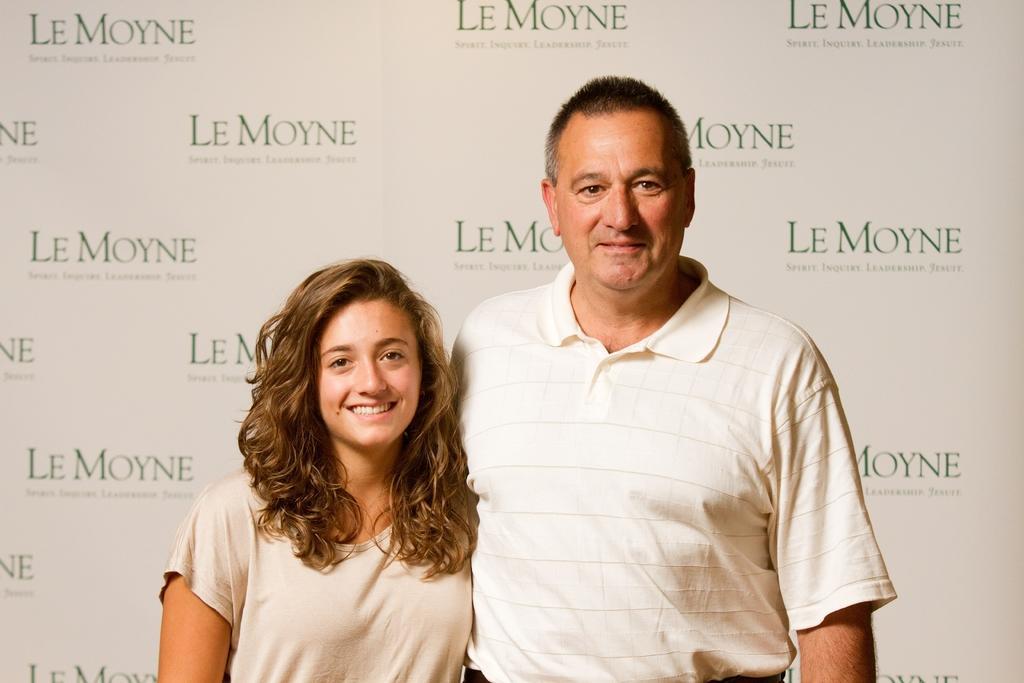Can you describe this image briefly? In this image, there are two persons standing and wearing clothes. 